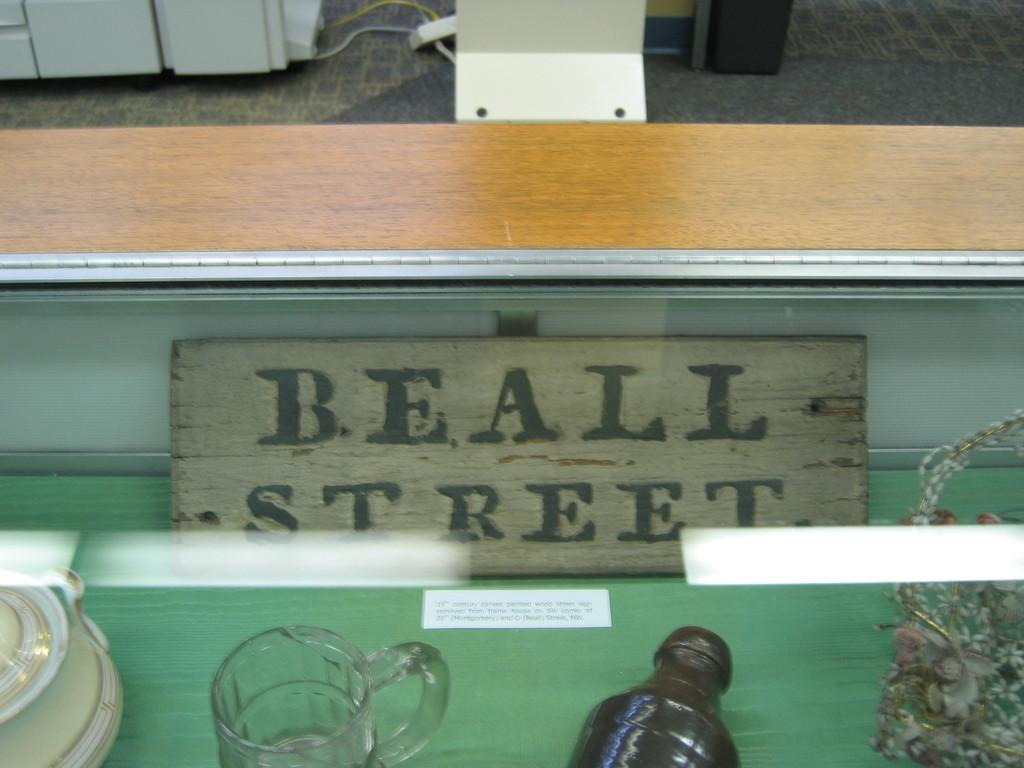<image>
Relay a brief, clear account of the picture shown. Sign saying Beall Street inside of a glass container. 